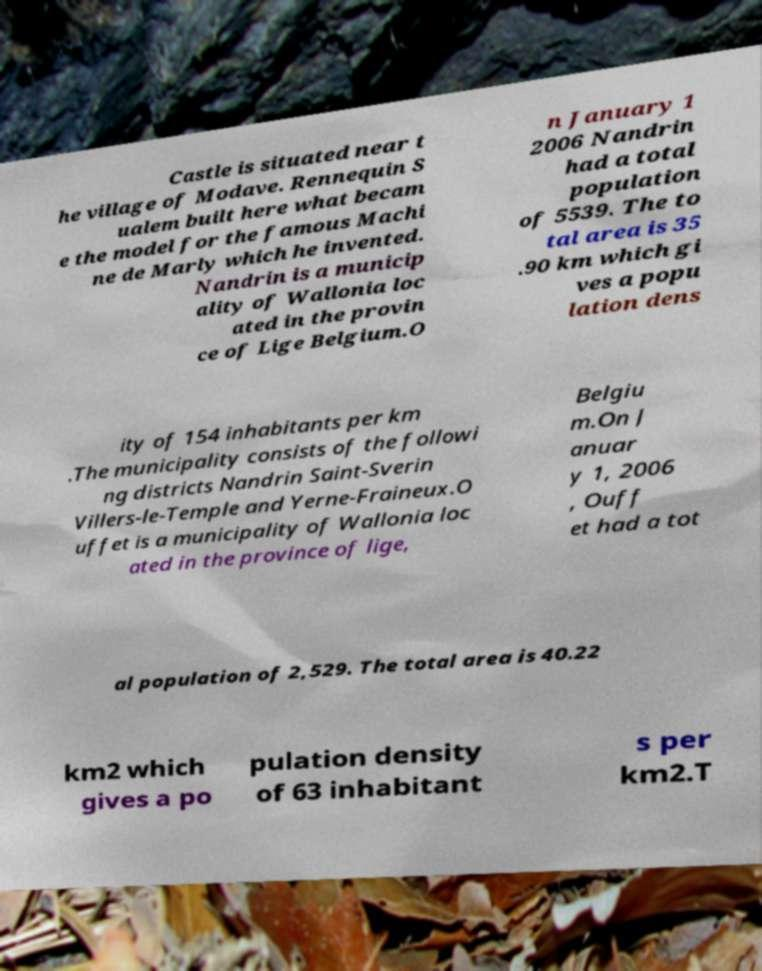Could you extract and type out the text from this image? Castle is situated near t he village of Modave. Rennequin S ualem built here what becam e the model for the famous Machi ne de Marly which he invented. Nandrin is a municip ality of Wallonia loc ated in the provin ce of Lige Belgium.O n January 1 2006 Nandrin had a total population of 5539. The to tal area is 35 .90 km which gi ves a popu lation dens ity of 154 inhabitants per km .The municipality consists of the followi ng districts Nandrin Saint-Sverin Villers-le-Temple and Yerne-Fraineux.O uffet is a municipality of Wallonia loc ated in the province of lige, Belgiu m.On J anuar y 1, 2006 , Ouff et had a tot al population of 2,529. The total area is 40.22 km2 which gives a po pulation density of 63 inhabitant s per km2.T 